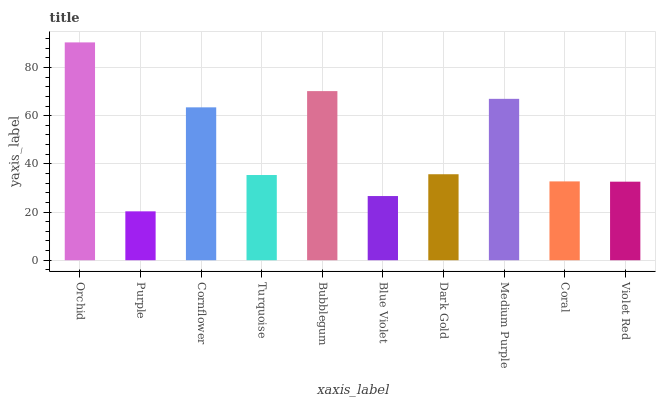Is Purple the minimum?
Answer yes or no. Yes. Is Orchid the maximum?
Answer yes or no. Yes. Is Cornflower the minimum?
Answer yes or no. No. Is Cornflower the maximum?
Answer yes or no. No. Is Cornflower greater than Purple?
Answer yes or no. Yes. Is Purple less than Cornflower?
Answer yes or no. Yes. Is Purple greater than Cornflower?
Answer yes or no. No. Is Cornflower less than Purple?
Answer yes or no. No. Is Dark Gold the high median?
Answer yes or no. Yes. Is Turquoise the low median?
Answer yes or no. Yes. Is Purple the high median?
Answer yes or no. No. Is Cornflower the low median?
Answer yes or no. No. 